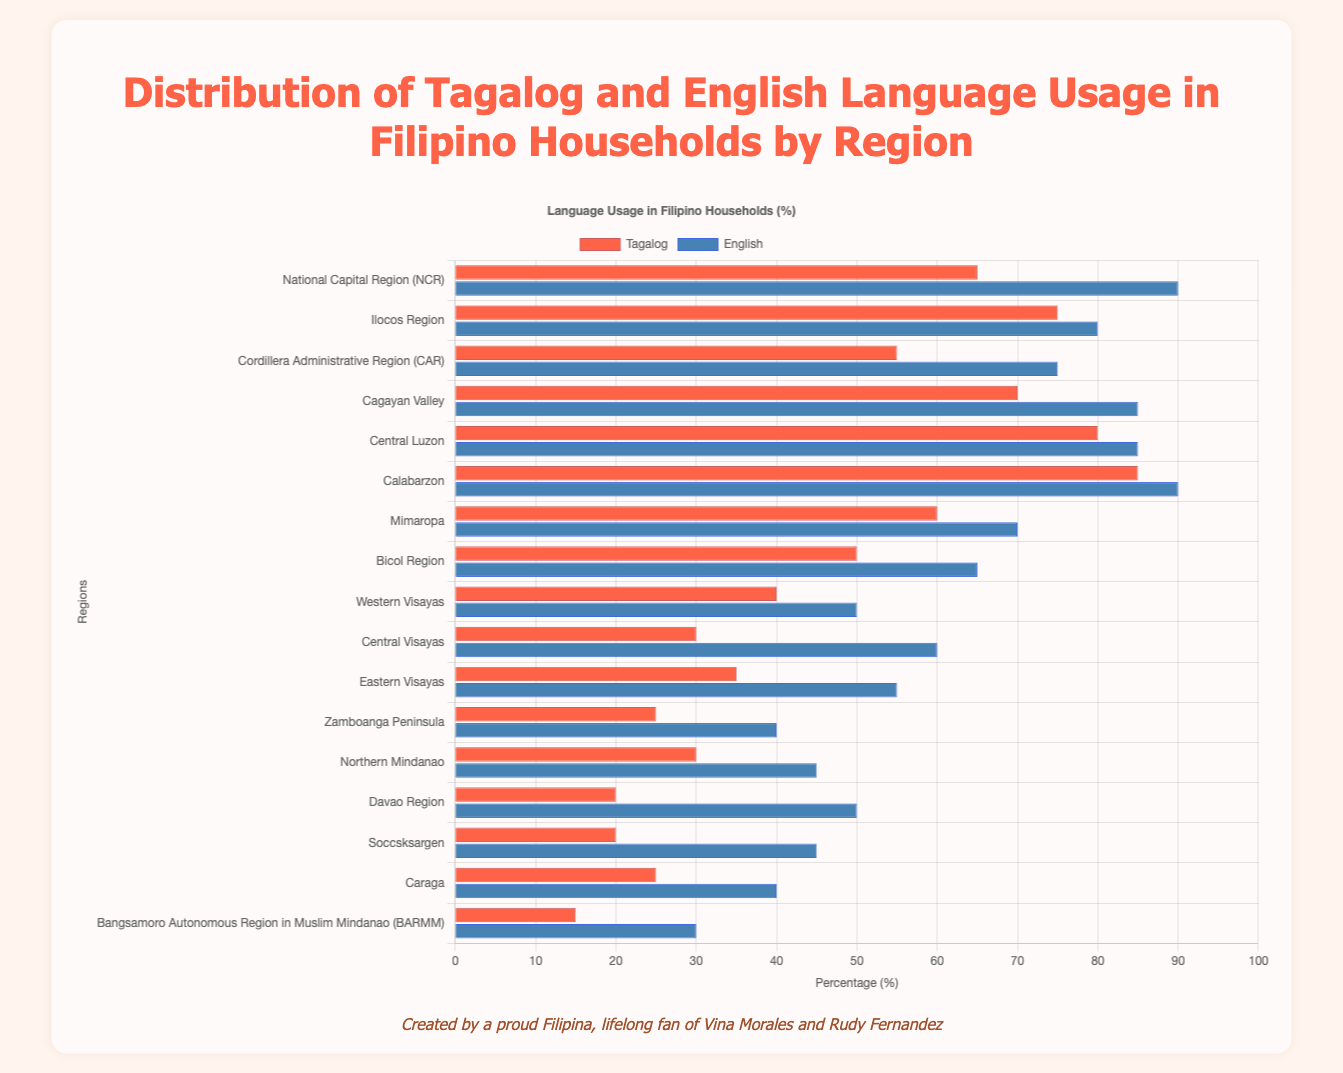Which region has the highest usage of Tagalog? From the figure, looking at the lengths of the red bars which represent Tagalog usage, the longest bar is for the Calabarzon region.
Answer: Calabarzon Which region has the highest usage of English? From the figure, observing the blue bars which show English usage, the longest bar is for both the National Capital Region (NCR) and Calabarzon, as they have the same maximum length.
Answer: NCR and Calabarzon Which region shows the lowest usage of Tagalog? By comparing the lengths of the red bars, the region with the shortest bar is the Bangsamoro Autonomous Region in Muslim Mindanao (BARMM).
Answer: BARMM Which has a higher percentage in English usage, Ilocos Region or Central Visayas? By comparing the blue bars for Ilocos Region and Central Visayas, Ilocos Region (80) has a higher percentage than Central Visayas (60).
Answer: Ilocos Region What is the difference in Tagalog usage between Central Luzon and Eastern Visayas? Tagalog usage in Central Luzon is 80%, and in Eastern Visayas is 35%. The difference is 80 - 35 = 45 percentage points.
Answer: 45 What's the average Tagalog usage in NCR, Central Luzon, and Calabarzon? Tagalog usage in NCR is 65%, Central Luzon is 80%, and Calabarzon is 85%. The average is (65 + 80 + 85) / 3 = 230 / 3 = approximately 76.67%.
Answer: 76.67 Which region has the closest English usage percentage to 50%? By observing the blue bars, the Western Visayas and Davao Region each have an English usage of 50%, which matches exactly.
Answer: Western Visayas and Davao Region Which has a smaller difference between Tagalog and English usage, Bicol Region or Mimaropa? Difference in Bicol Region: 65 (English) - 50 (Tagalog) = 15. Difference in Mimaropa: 70 (English) - 60 (Tagalog) = 10. Mimaropa has a smaller difference.
Answer: Mimaropa Which region has the same percentage of Tagalog usage as the Ilocos Region? By looking at the red bars, Ilocos Region has a 75% Tagalog usage. The Cagayan Valley also has a Tagalog usage of 75%.
Answer: Cagayan Valley 